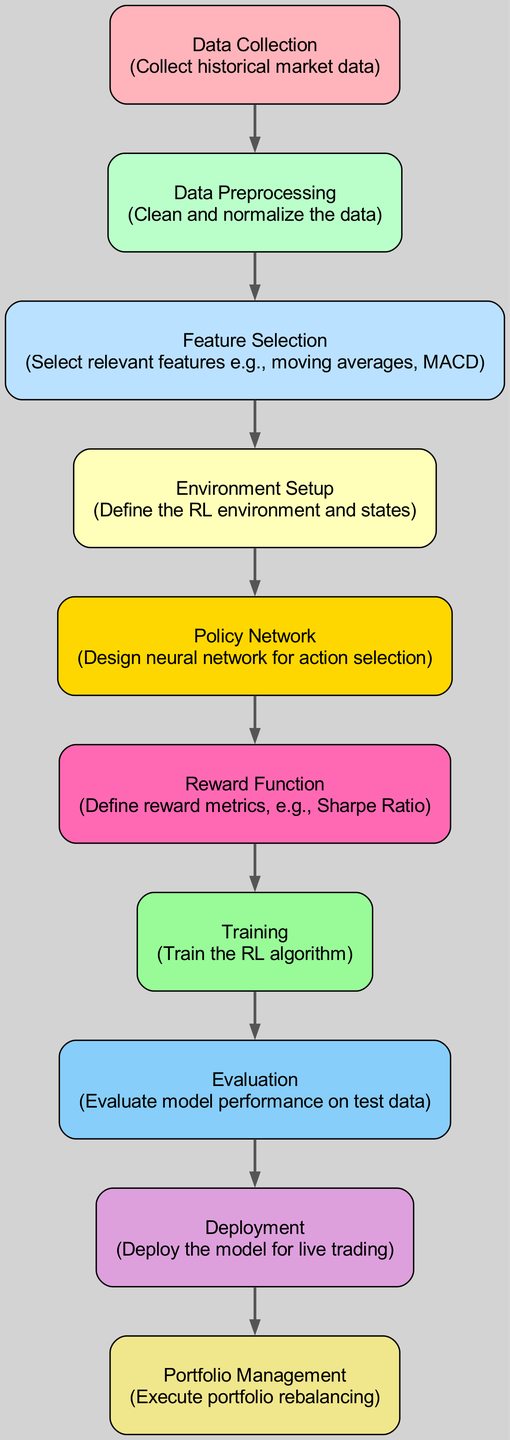What is the first step in the diagram? The first step in the diagram is "Data Collection," which involves gathering historical market data.
Answer: Data Collection How many nodes are in the diagram? By counting the specified nodes in the data provided, there are 10 distinct nodes listed in the diagram.
Answer: 10 What is the reward function related to in the diagram? The reward function is connected to the policy network, indicating that it measures the performance metrics derived from the actions taken by the network.
Answer: Policy Network Which node comes after "Training"? Following the training phase in the diagram, the next step is "Evaluation," where the model performance is assessed against test data.
Answer: Evaluation What color represents the "Deployment" node in the diagram? The "Deployment" node is represented in plum color according to the specified color mapping in the diagram.
Answer: Plum What is the relationship between "Feature Selection" and "Environment Setup"? The relationship is directional; "Feature Selection" feeds into "Environment Setup," indicating that selected features are utilized in defining the RL environment and states.
Answer: Feature Selection → Environment Setup What type of model is designed during the "Policy Network" phase? This phase involves the design of a neural network specifically for action selection within the reinforcement learning framework.
Answer: Neural Network What happens immediately after "Evaluation"? Immediately following the evaluation of model performance, the next step is the deployment of the model for live trading.
Answer: Deployment Which node is associated with portfolio rebalancing? The final node in the flow that handles the execution of portfolio rebalancing is "Portfolio Management."
Answer: Portfolio Management 